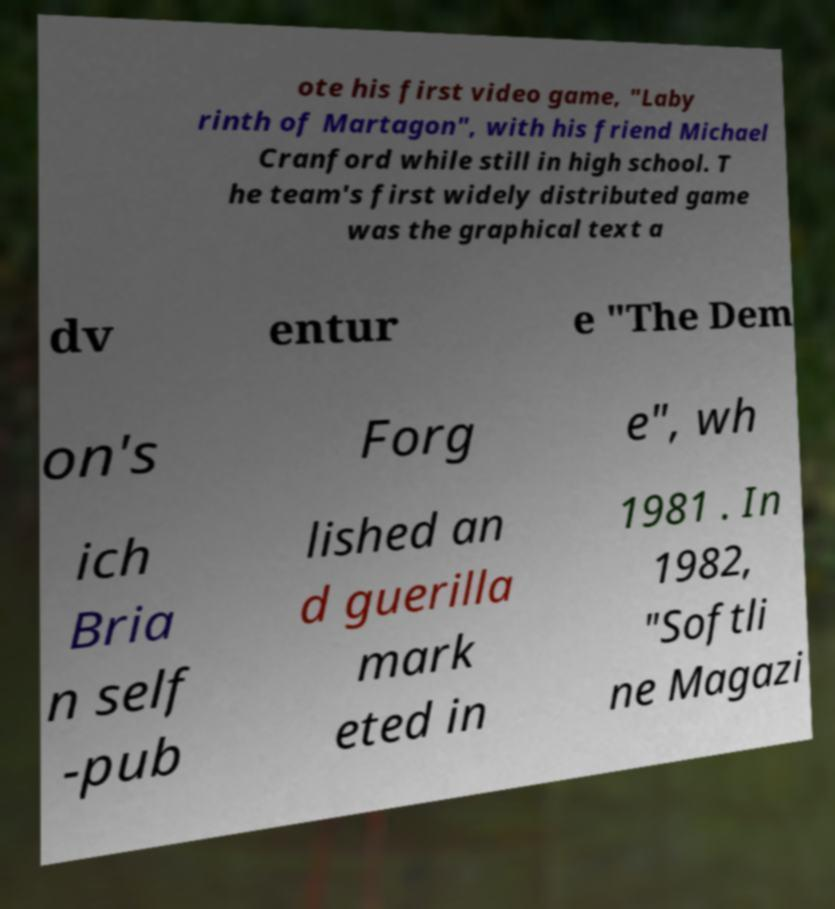There's text embedded in this image that I need extracted. Can you transcribe it verbatim? ote his first video game, "Laby rinth of Martagon", with his friend Michael Cranford while still in high school. T he team's first widely distributed game was the graphical text a dv entur e "The Dem on's Forg e", wh ich Bria n self -pub lished an d guerilla mark eted in 1981 . In 1982, "Softli ne Magazi 